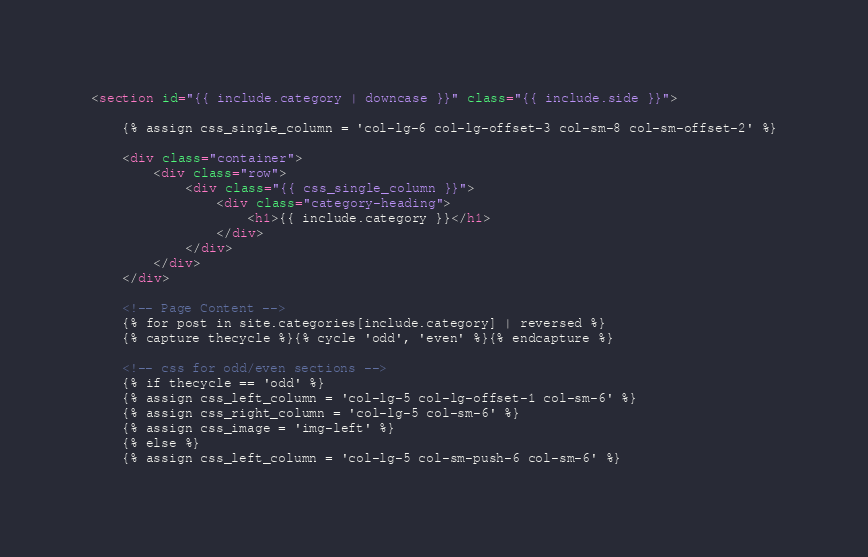Convert code to text. <code><loc_0><loc_0><loc_500><loc_500><_HTML_><section id="{{ include.category | downcase }}" class="{{ include.side }}">

    {% assign css_single_column = 'col-lg-6 col-lg-offset-3 col-sm-8 col-sm-offset-2' %}

    <div class="container">
        <div class="row">
            <div class="{{ css_single_column }}">
                <div class="category-heading">
                    <h1>{{ include.category }}</h1>
                </div>
            </div>
        </div>
    </div>

    <!-- Page Content -->
    {% for post in site.categories[include.category] | reversed %}
    {% capture thecycle %}{% cycle 'odd', 'even' %}{% endcapture %}

    <!-- css for odd/even sections -->
    {% if thecycle == 'odd' %}
    {% assign css_left_column = 'col-lg-5 col-lg-offset-1 col-sm-6' %}
    {% assign css_right_column = 'col-lg-5 col-sm-6' %}
    {% assign css_image = 'img-left' %}
    {% else %}
    {% assign css_left_column = 'col-lg-5 col-sm-push-6 col-sm-6' %}</code> 